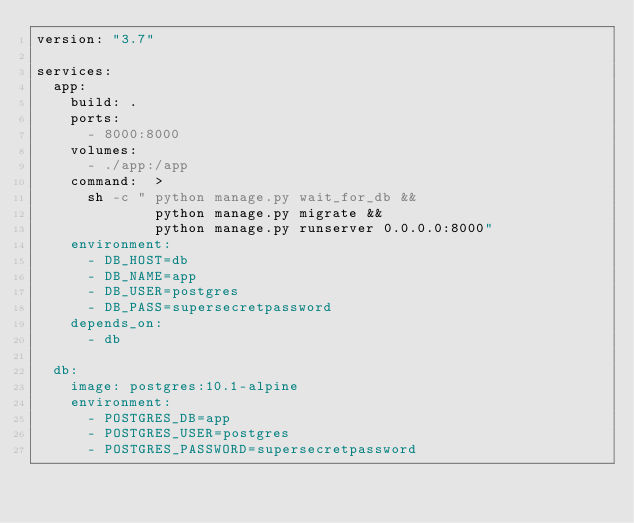<code> <loc_0><loc_0><loc_500><loc_500><_YAML_>version: "3.7"

services:
  app:
    build: .
    ports:
      - 8000:8000
    volumes:
      - ./app:/app
    command:  >
      sh -c " python manage.py wait_for_db &&
              python manage.py migrate &&
              python manage.py runserver 0.0.0.0:8000"
    environment:
      - DB_HOST=db
      - DB_NAME=app
      - DB_USER=postgres
      - DB_PASS=supersecretpassword
    depends_on:
      - db      

  db:
    image: postgres:10.1-alpine
    environment:
      - POSTGRES_DB=app
      - POSTGRES_USER=postgres
      - POSTGRES_PASSWORD=supersecretpassword</code> 